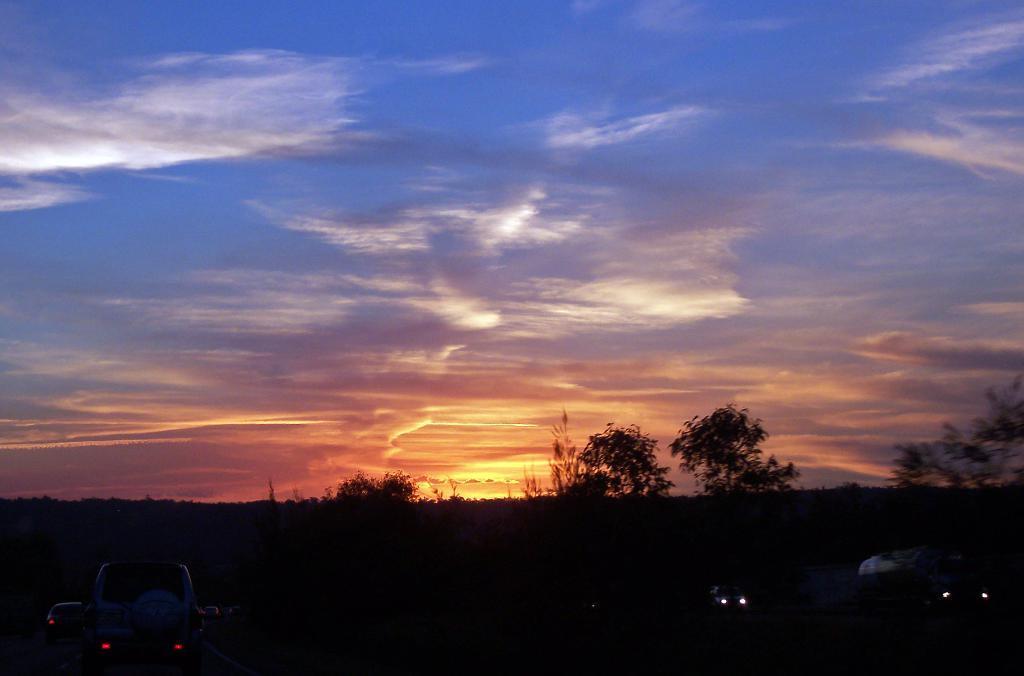How would you summarize this image in a sentence or two? In this image we can see some vehicles, trees, road and other objects. At the top of the image there is the sky. 